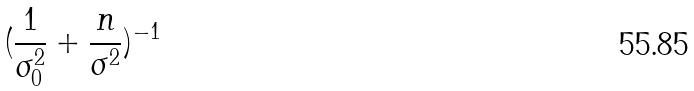Convert formula to latex. <formula><loc_0><loc_0><loc_500><loc_500>( \frac { 1 } { \sigma _ { 0 } ^ { 2 } } + \frac { n } { \sigma ^ { 2 } } ) ^ { - 1 }</formula> 